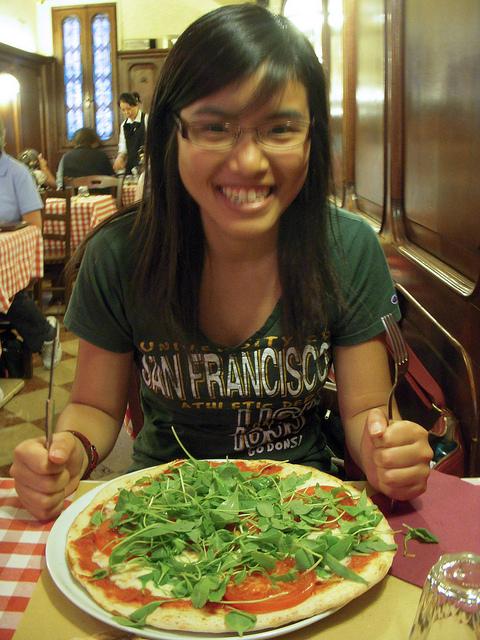What ethnicity is the girl?
Short answer required. Chinese. What food dish is this?
Concise answer only. Pizza. What city is on the girls shirt?
Answer briefly. San francisco. 